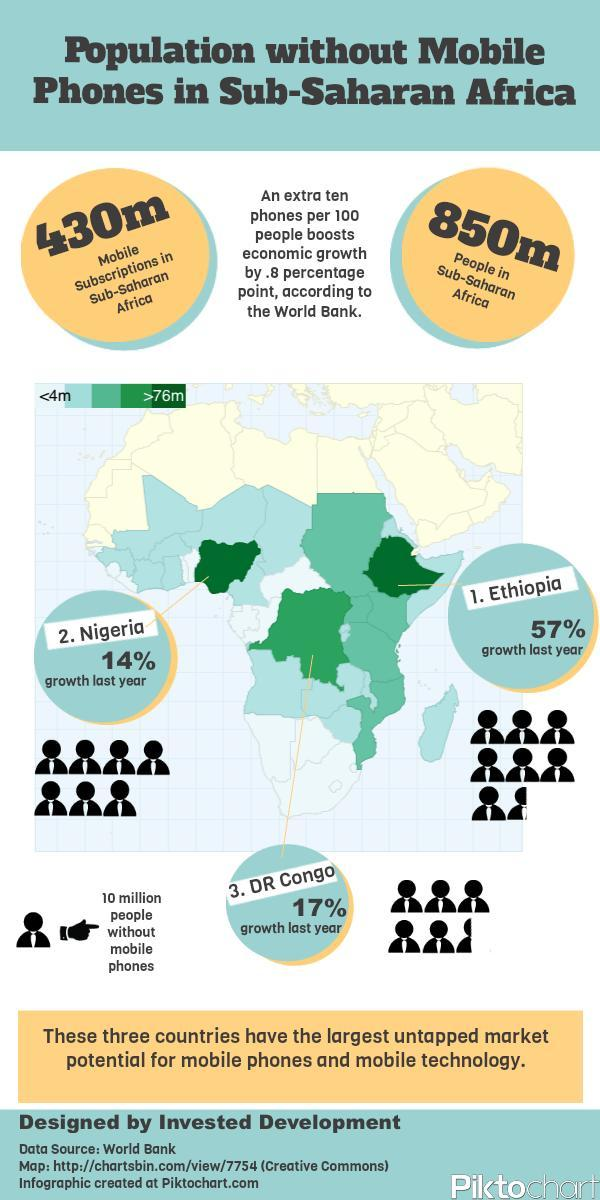What is the number of people without mobile subscriptions?
Answer the question with a short phrase. 420m What is the percentage growth of Nigeria and DR Congo, taken together? 31% What is the percentage growth of Ethiopia and Nigeria, taken together? 71% What is the percentage growth of Ethiopia and DR Congo, taken together? 74% 